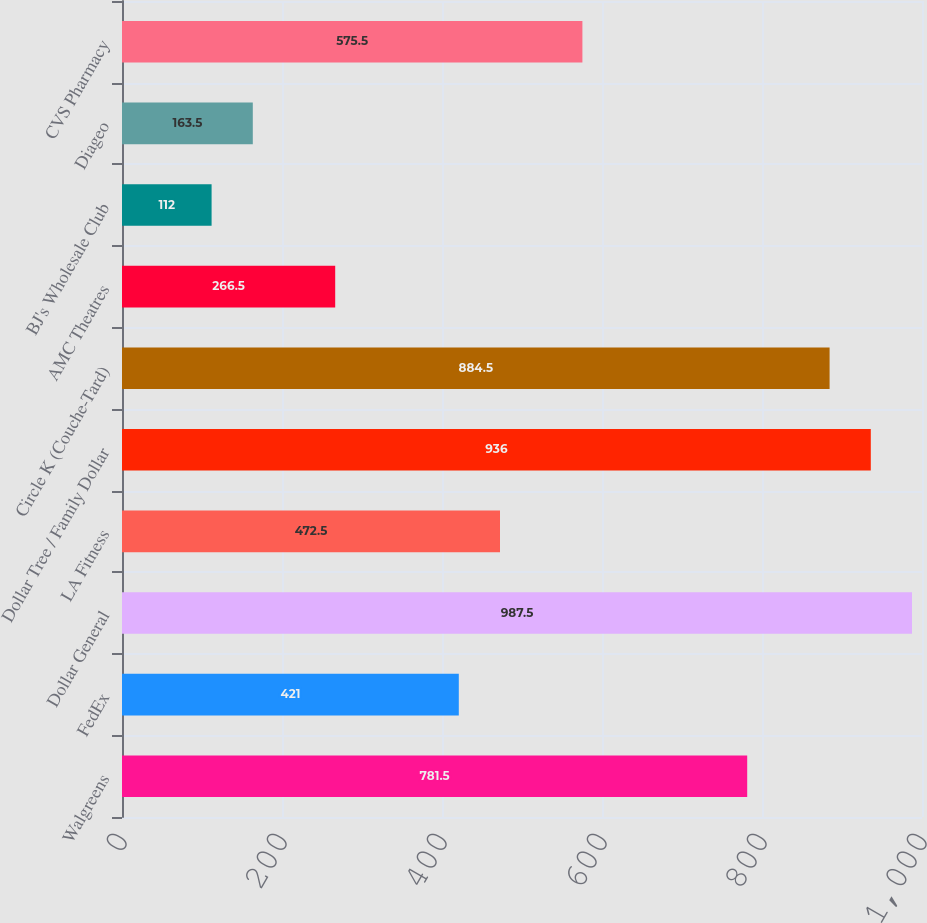<chart> <loc_0><loc_0><loc_500><loc_500><bar_chart><fcel>Walgreens<fcel>FedEx<fcel>Dollar General<fcel>LA Fitness<fcel>Dollar Tree / Family Dollar<fcel>Circle K (Couche-Tard)<fcel>AMC Theatres<fcel>BJ's Wholesale Club<fcel>Diageo<fcel>CVS Pharmacy<nl><fcel>781.5<fcel>421<fcel>987.5<fcel>472.5<fcel>936<fcel>884.5<fcel>266.5<fcel>112<fcel>163.5<fcel>575.5<nl></chart> 